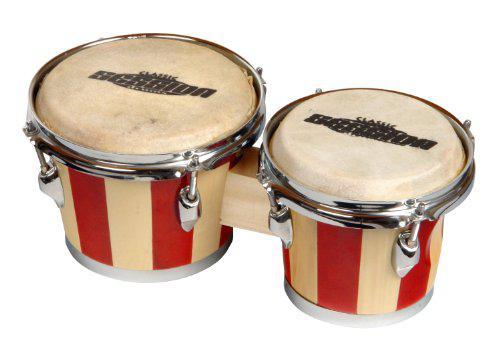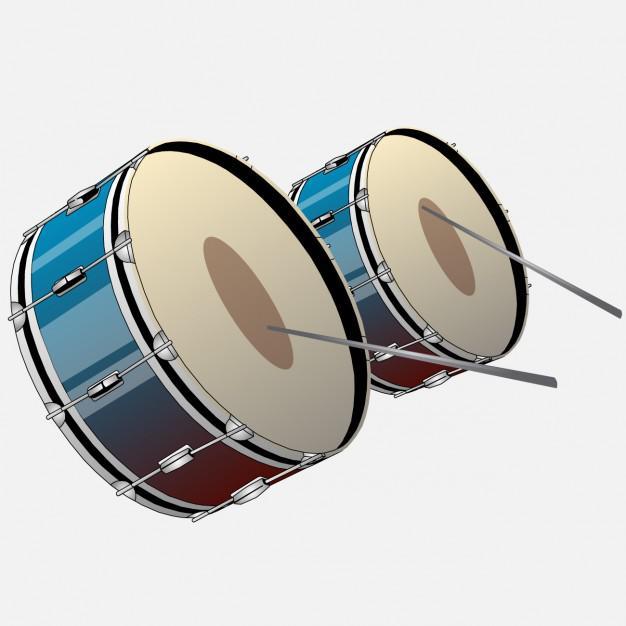The first image is the image on the left, the second image is the image on the right. Analyze the images presented: Is the assertion "The right image shows connected drums with solid-colored sides and white tops, and the left image features two drumsticks and a cylinder shape." valid? Answer yes or no. No. 